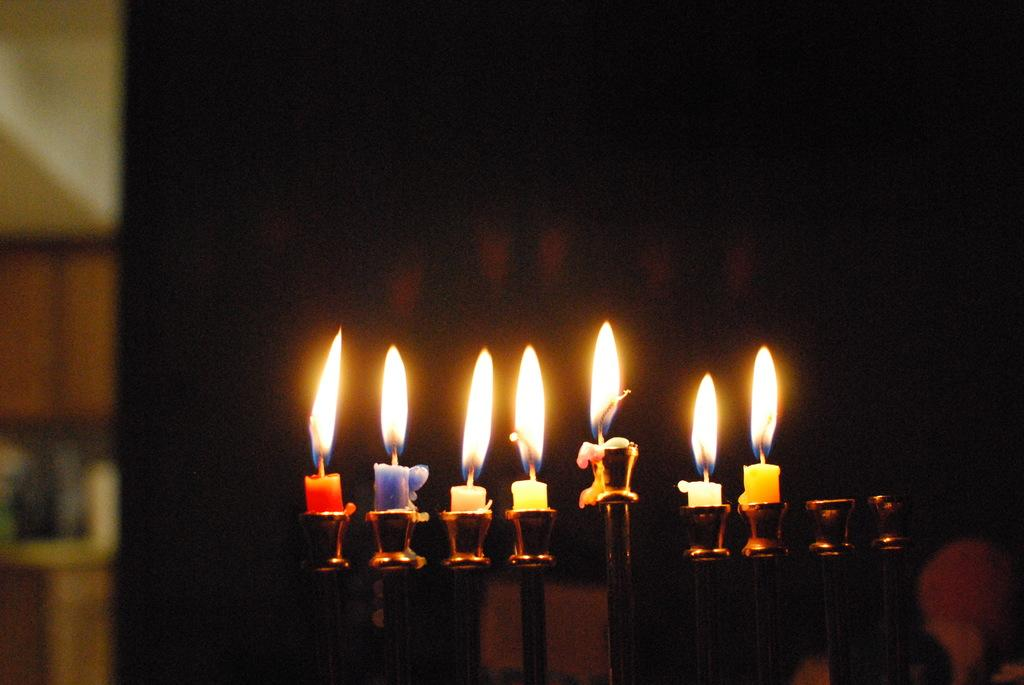What objects are in the foreground of the image? There are candles and candle stands in the foreground of the image. Can you describe the background of the image? The background of the image is blurry. How many scarecrows can be seen in the image? There are no scarecrows present in the image. What type of horses are depicted in the image? There are no horses depicted in the image. 